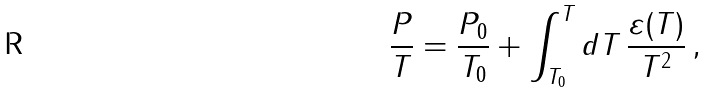Convert formula to latex. <formula><loc_0><loc_0><loc_500><loc_500>\frac { P } { T } = \frac { P _ { 0 } } { T _ { 0 } } + \int _ { T _ { 0 } } ^ { T } d T \, \frac { \varepsilon ( T ) } { T ^ { 2 } } \, ,</formula> 